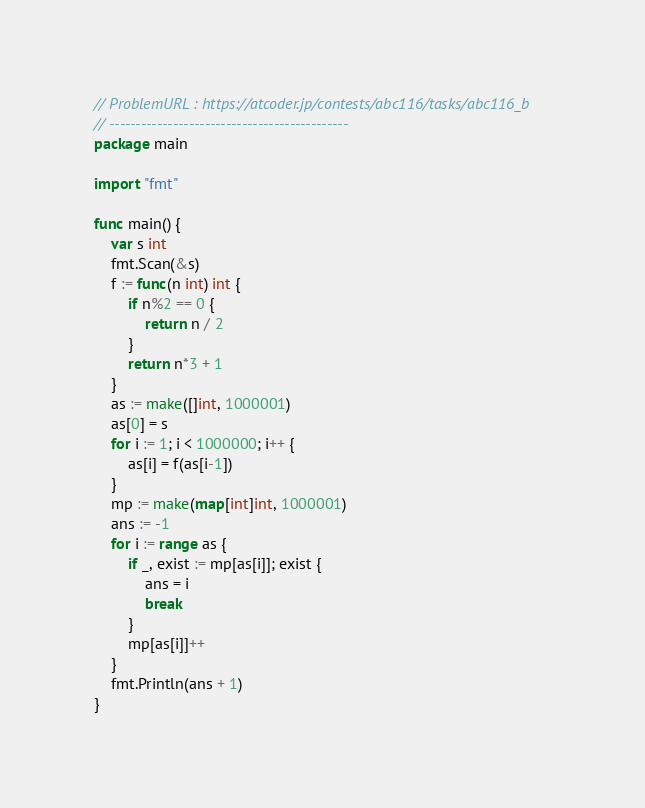Convert code to text. <code><loc_0><loc_0><loc_500><loc_500><_Go_>// ProblemURL : https://atcoder.jp/contests/abc116/tasks/abc116_b
// ---------------------------------------------
package main

import "fmt"

func main() {
	var s int
	fmt.Scan(&s)
	f := func(n int) int {
		if n%2 == 0 {
			return n / 2
		}
		return n*3 + 1
	}
	as := make([]int, 1000001)
	as[0] = s
	for i := 1; i < 1000000; i++ {
		as[i] = f(as[i-1])
	}
	mp := make(map[int]int, 1000001)
	ans := -1
	for i := range as {
		if _, exist := mp[as[i]]; exist {
			ans = i
			break
		}
		mp[as[i]]++
	}
	fmt.Println(ans + 1)
}
</code> 